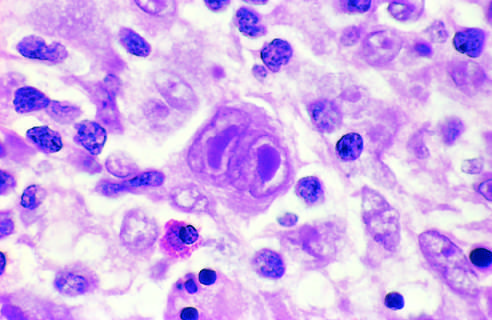what is surrounded by lymphocytes, macrophages, and an eosinophil?
Answer the question using a single word or phrase. A binucleate reed-sternberg cell 